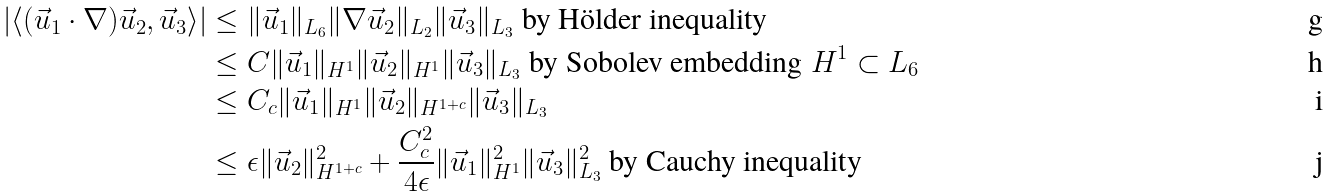Convert formula to latex. <formula><loc_0><loc_0><loc_500><loc_500>| \langle ( \vec { u } _ { 1 } \cdot \nabla ) \vec { u } _ { 2 } , \vec { u } _ { 3 } \rangle | & \leq \| \vec { u } _ { 1 } \| _ { L _ { 6 } } \| \nabla \vec { u } _ { 2 } \| _ { L _ { 2 } } \| \vec { u } _ { 3 } \| _ { L _ { 3 } } \text { by H\"older inequality} \\ & \leq C \| \vec { u } _ { 1 } \| _ { H ^ { 1 } } \| \vec { u } _ { 2 } \| _ { H ^ { 1 } } \| \vec { u } _ { 3 } \| _ { L _ { 3 } } \text { by Sobolev embedding } H ^ { 1 } \subset L _ { 6 } \\ & \leq C _ { c } \| \vec { u } _ { 1 } \| _ { H ^ { 1 } } \| \vec { u } _ { 2 } \| _ { H ^ { 1 + c } } \| \vec { u } _ { 3 } \| _ { L _ { 3 } } \\ & \leq \epsilon \| \vec { u } _ { 2 } \| _ { H ^ { 1 + c } } ^ { 2 } + \frac { C _ { c } ^ { 2 } } { 4 \epsilon } \| \vec { u } _ { 1 } \| ^ { 2 } _ { H ^ { 1 } } \| \vec { u } _ { 3 } \| _ { L _ { 3 } } ^ { 2 } \text { by Cauchy inequality}</formula> 